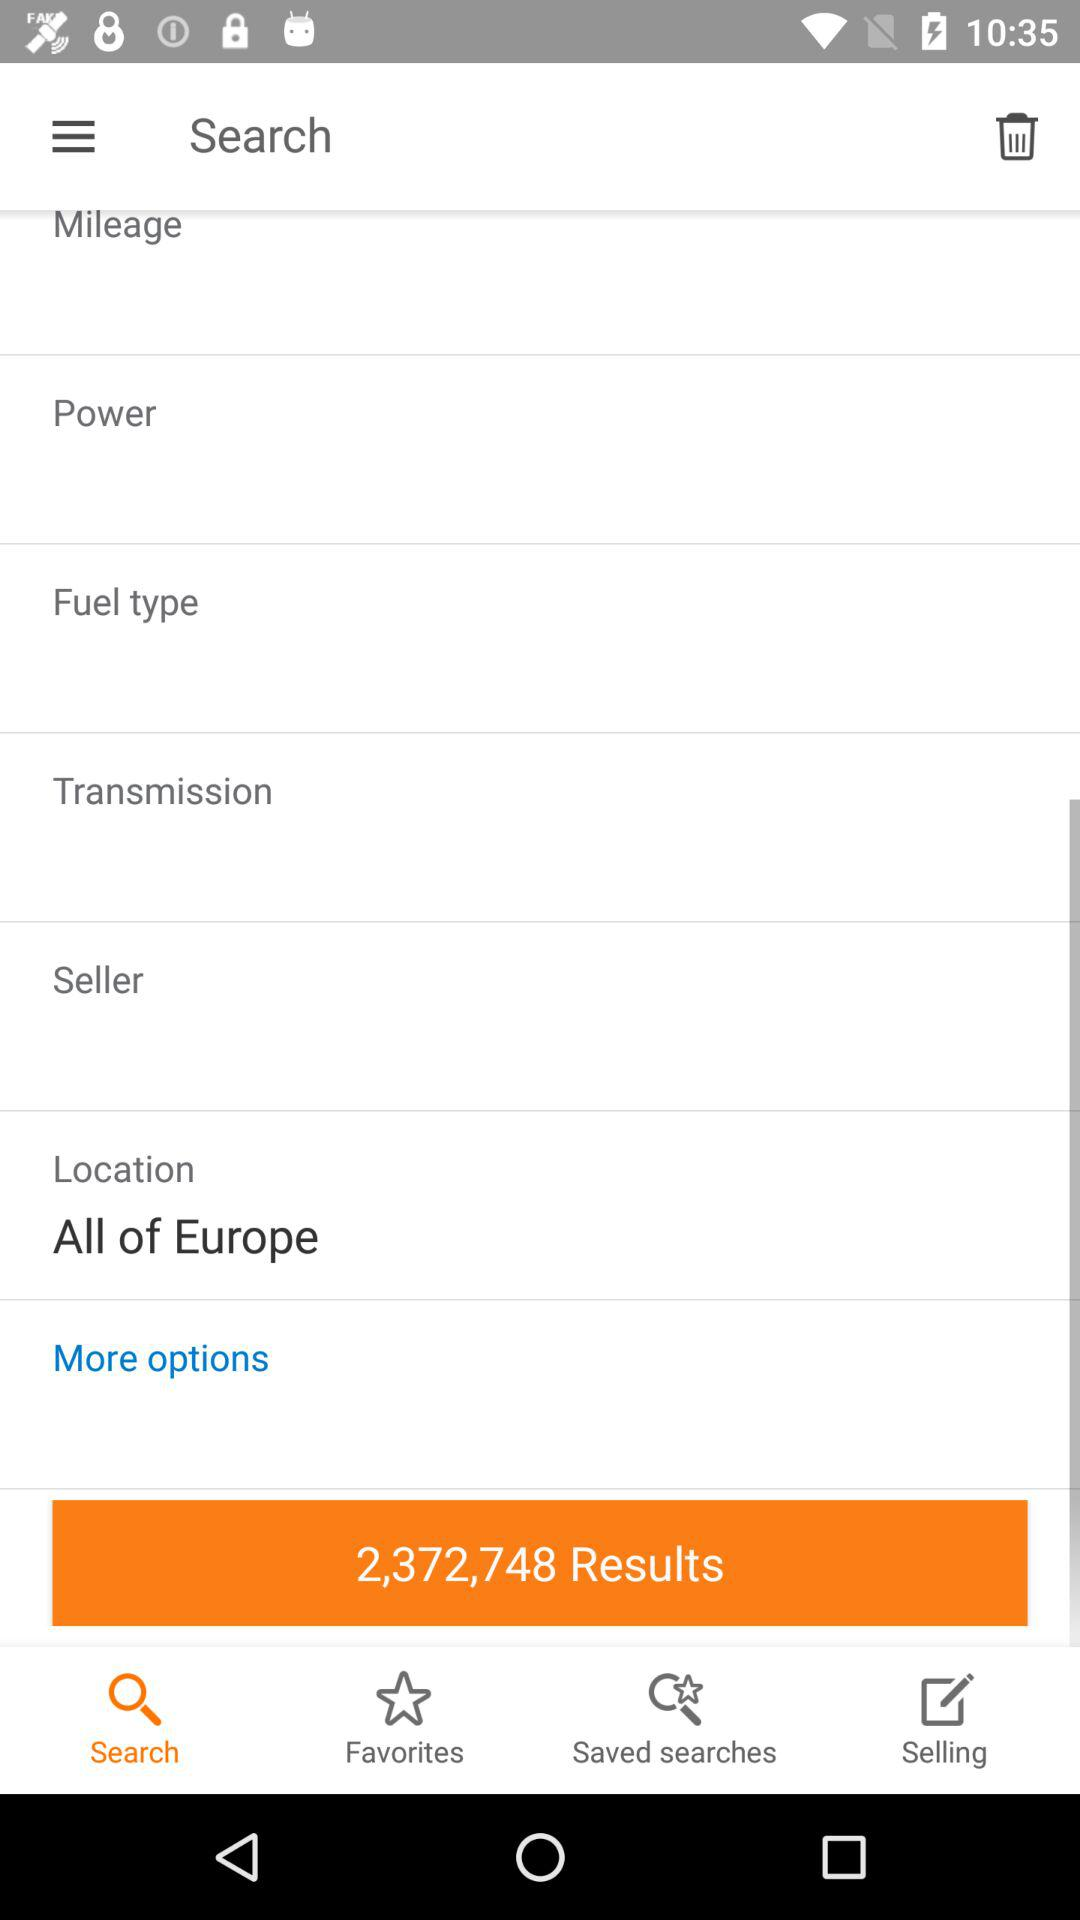Which option is selected? The selected option is "Search". 